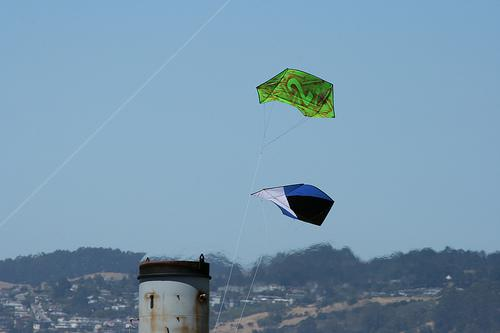Question: what is in the sky?
Choices:
A. Birds.
B. Airplanes.
C. Clouds.
D. Kite.
Answer with the letter. Answer: D Question: what color is the smokestack?
Choices:
A. Grey.
B. Black.
C. White.
D. Silver.
Answer with the letter. Answer: A Question: what is coming out of the building?
Choices:
A. People.
B. Exhaust.
C. Dogs.
D. Smoke.
Answer with the letter. Answer: D 